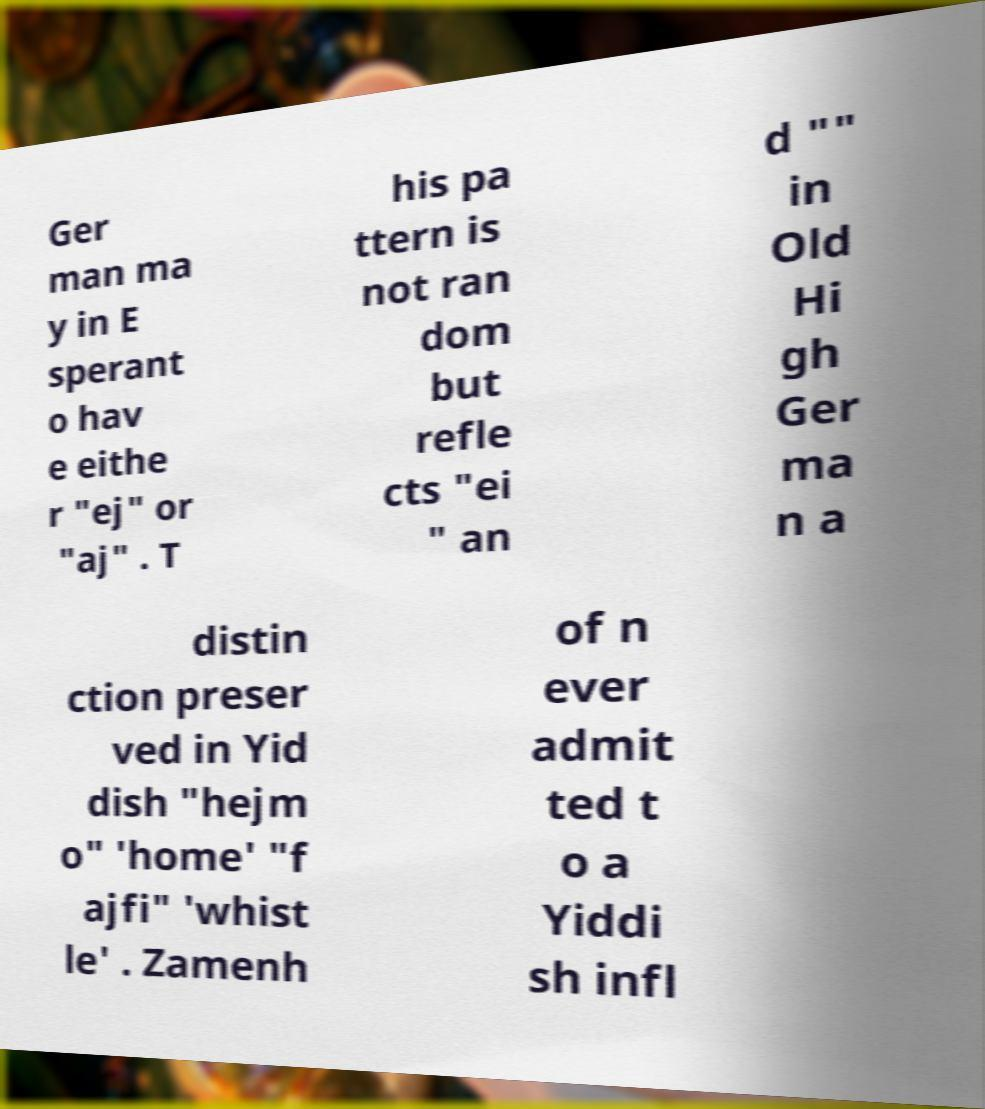Please read and relay the text visible in this image. What does it say? Ger man ma y in E sperant o hav e eithe r "ej" or "aj" . T his pa ttern is not ran dom but refle cts "ei " an d "" in Old Hi gh Ger ma n a distin ction preser ved in Yid dish "hejm o" 'home' "f ajfi" 'whist le' . Zamenh of n ever admit ted t o a Yiddi sh infl 